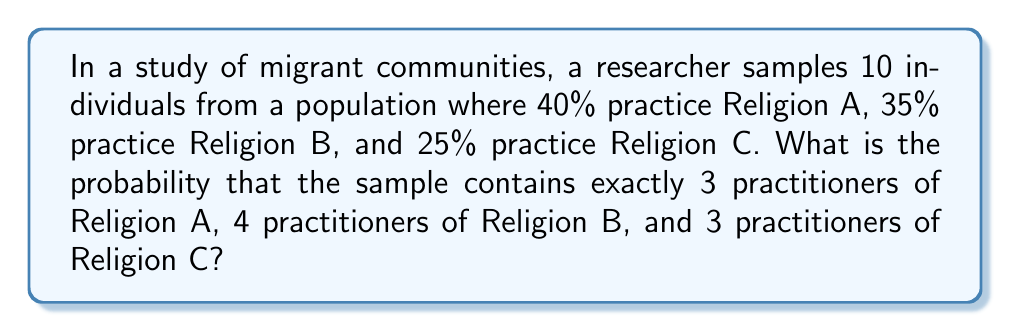Solve this math problem. To solve this problem, we'll use the multinomial distribution, which is appropriate for situations with more than two categories.

1) The probability mass function for the multinomial distribution is:

   $$P(X_1 = x_1, X_2 = x_2, ..., X_k = x_k) = \frac{n!}{x_1! x_2! ... x_k!} p_1^{x_1} p_2^{x_2} ... p_k^{x_k}$$

   Where:
   - $n$ is the total number of trials (in this case, 10 migrants)
   - $x_i$ is the number of occurrences of each category
   - $p_i$ is the probability of each category

2) In our case:
   - $n = 10$
   - $x_1 = 3$ (Religion A), $x_2 = 4$ (Religion B), $x_3 = 3$ (Religion C)
   - $p_1 = 0.40$ (Religion A), $p_2 = 0.35$ (Religion B), $p_3 = 0.25$ (Religion C)

3) Plugging these values into the formula:

   $$P(X_1 = 3, X_2 = 4, X_3 = 3) = \frac{10!}{3! 4! 3!} (0.40)^3 (0.35)^4 (0.25)^3$$

4) Calculating step by step:
   
   $$= \frac{10 \cdot 9 \cdot 8 \cdot 7 \cdot 6 \cdot 5!}{(3 \cdot 2 \cdot 1)(4 \cdot 3 \cdot 2 \cdot 1)(3 \cdot 2 \cdot 1)} \cdot 0.064 \cdot 0.014883 \cdot 0.015625$$
   
   $$= \frac{151200}{144} \cdot 0.000014883$$
   
   $$= 1050 \cdot 0.000014883$$
   
   $$= 0.015627150$$

5) Rounding to 4 decimal places:

   $$= 0.0156$$

This represents a 1.56% chance of observing exactly this distribution in a random sample of 10 migrants from the given population.
Answer: 0.0156 